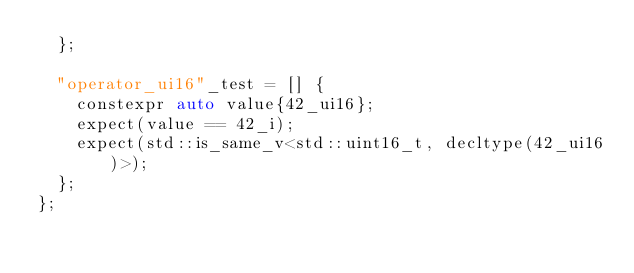Convert code to text. <code><loc_0><loc_0><loc_500><loc_500><_C++_>  };

  "operator_ui16"_test = [] {
    constexpr auto value{42_ui16};
    expect(value == 42_i);
    expect(std::is_same_v<std::uint16_t, decltype(42_ui16)>);
  };
};</code> 